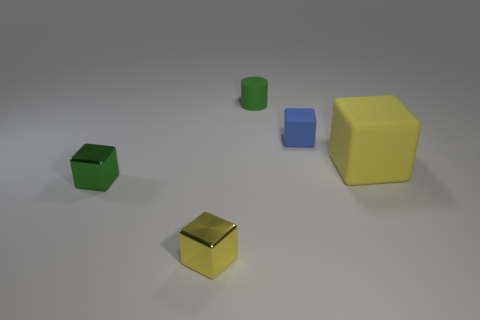Add 3 small blue blocks. How many objects exist? 8 Subtract all cubes. How many objects are left? 1 Subtract all small shiny blocks. Subtract all rubber blocks. How many objects are left? 1 Add 5 matte blocks. How many matte blocks are left? 7 Add 2 yellow shiny cubes. How many yellow shiny cubes exist? 3 Subtract 1 blue cubes. How many objects are left? 4 